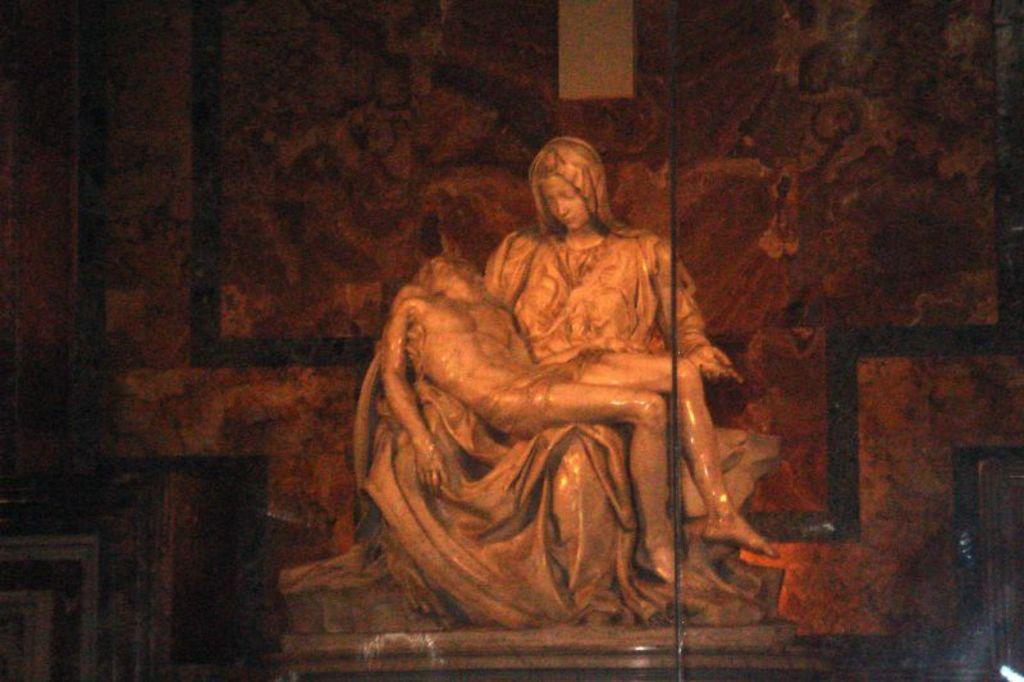What type of marble is being used to decorate the drain in the image? There is no drain or marble present in the image. Is the crown made of a specific type of material in the image? There is no crown present in the image. 